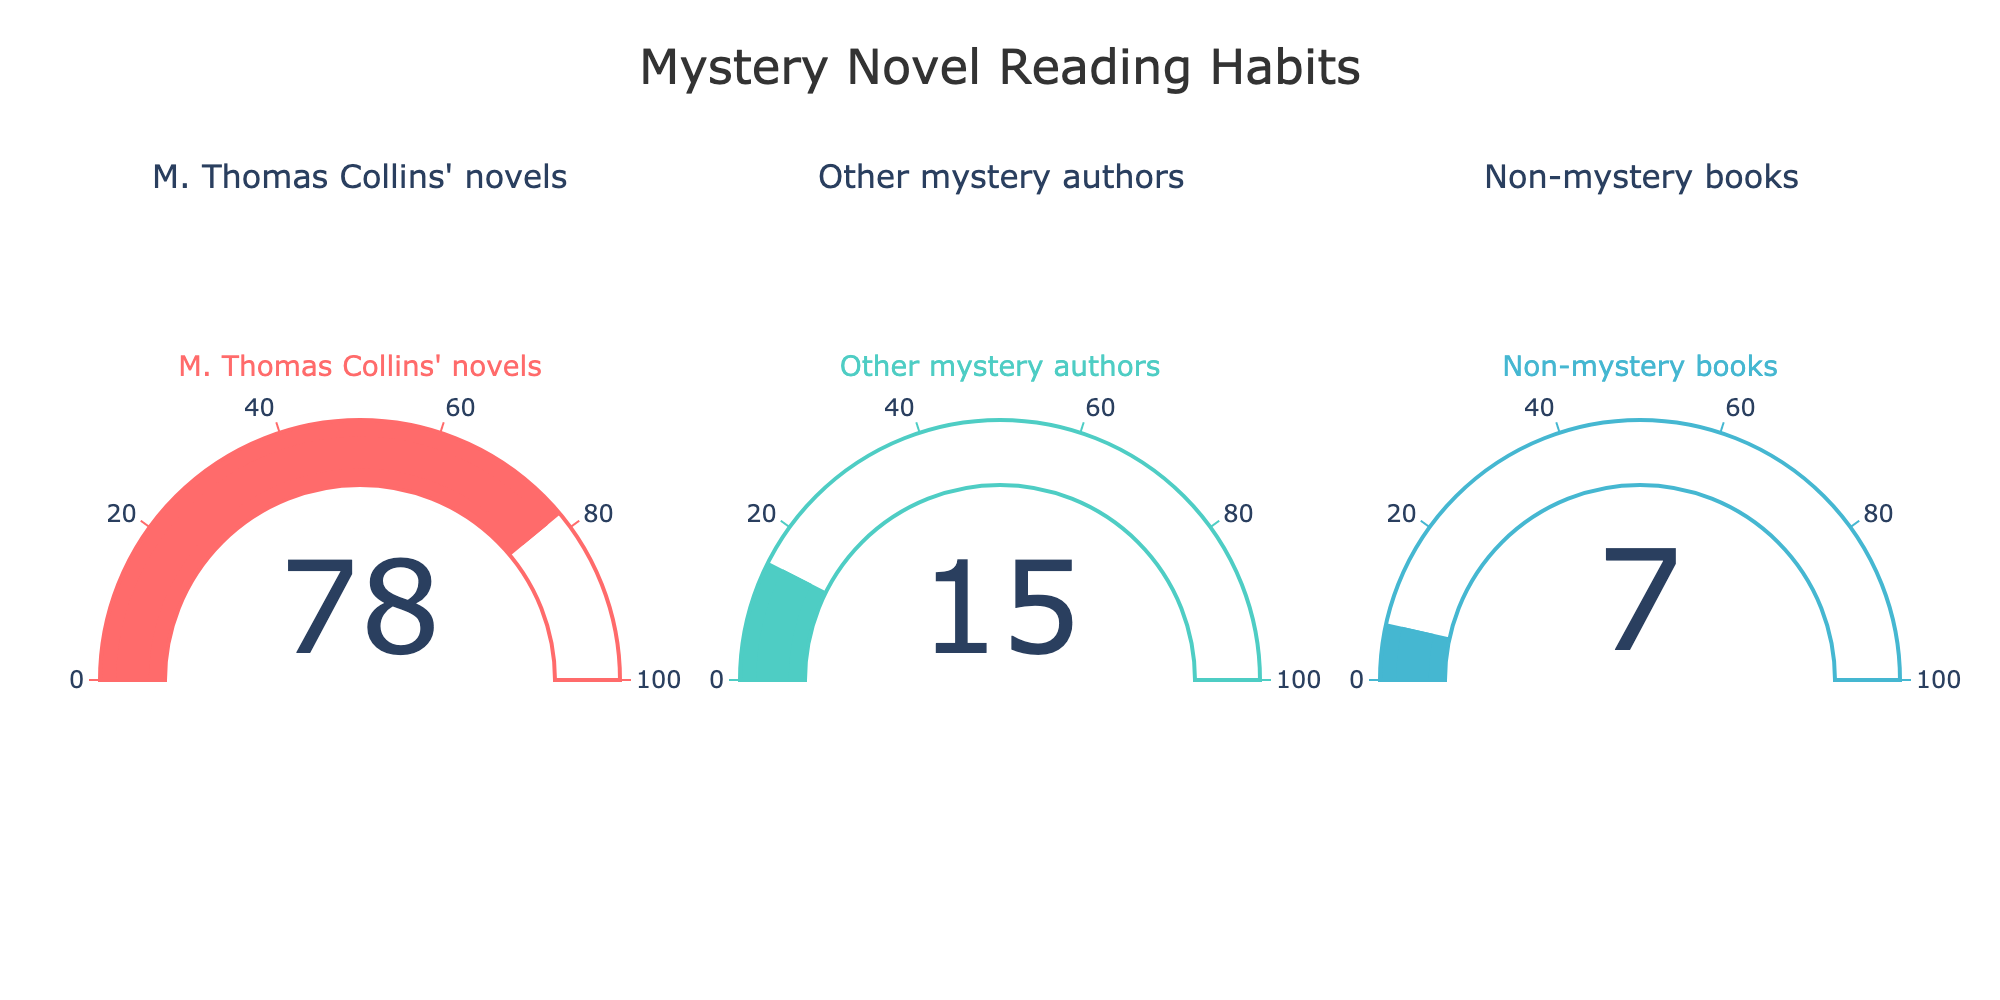What is the title of the figure? The main title is displayed at the top center of the figure, which reads "Mystery Novel Reading Habits".
Answer: Mystery Novel Reading Habits How many categories of books are presented in the figure? There are three distinct gauges in the figure, each representing a different category of books.
Answer: 3 What is the percentage of M. Thomas Collins' novels read in the last year? The gauge that corresponds to M. Thomas Collins' novels shows a percentage value of 78.
Answer: 78 Which category has the smallest percentage reading? The gauge for "Non-mystery books" shows a percentage value of 7, which is the smallest among the categories.
Answer: Non-mystery books What is the total percentage of mystery novels read (both M. Thomas Collins' and other mystery authors) in the last year? The percentages for M. Thomas Collins' novels and other mystery authors are 78 and 15 respectively. Adding these together gives us 78 + 15 = 93.
Answer: 93 By how much does the percentage of M. Thomas Collins' novels read exceed the percentage of other mystery authors' novels read? The percentage of M. Thomas Collins' novels read is 78, and the percentage for other mystery authors is 15. The difference is 78 - 15 = 63.
Answer: 63 What is the average percentage of books read across all categories? To find the average, add the percentages of all categories (78, 15, and 7) and then divide by the number of categories (3). (78 + 15 + 7) / 3 = 100 / 3 ≈ 33.33.
Answer: 33.33 Which category has a percentage reading that is closest to the average percentage? The average percentage is approximately 33.33. Non-mystery books are 7, other mystery authors are 15, and M. Thomas Collins' novels are 78. The closest value to 33.33 is 15 from other mystery authors.
Answer: Other mystery authors In which gauge does the bar occupy more than half of the gauge range? The gauge range is from 0 to 100. The bar occupies more than half the range if the percentage is greater than 50. The gauge for M. Thomas Collins' novels shows a percentage of 78, which is greater than 50.
Answer: M. Thomas Collins' novels 